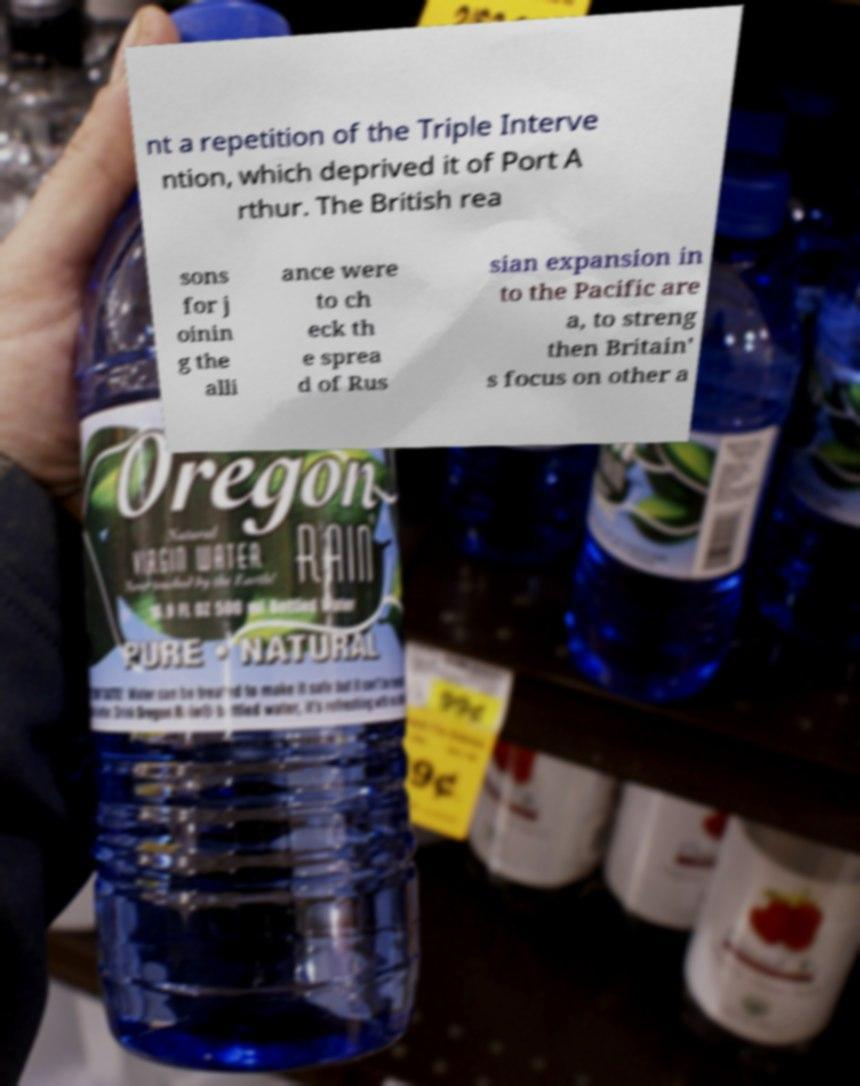Can you read and provide the text displayed in the image?This photo seems to have some interesting text. Can you extract and type it out for me? nt a repetition of the Triple Interve ntion, which deprived it of Port A rthur. The British rea sons for j oinin g the alli ance were to ch eck th e sprea d of Rus sian expansion in to the Pacific are a, to streng then Britain' s focus on other a 